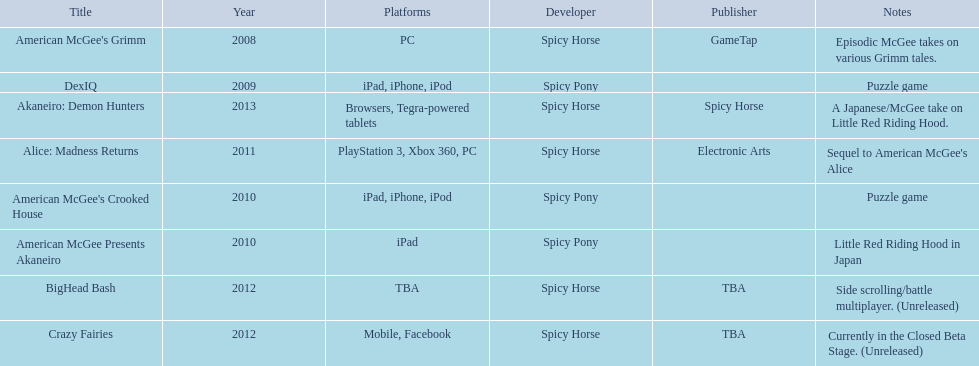Which spicy horse titles are shown? American McGee's Grimm, DexIQ, American McGee Presents Akaneiro, American McGee's Crooked House, Alice: Madness Returns, BigHead Bash, Crazy Fairies, Akaneiro: Demon Hunters. Of those, which are for the ipad? DexIQ, American McGee Presents Akaneiro, American McGee's Crooked House. Which of those are not for the iphone or ipod? American McGee Presents Akaneiro. 